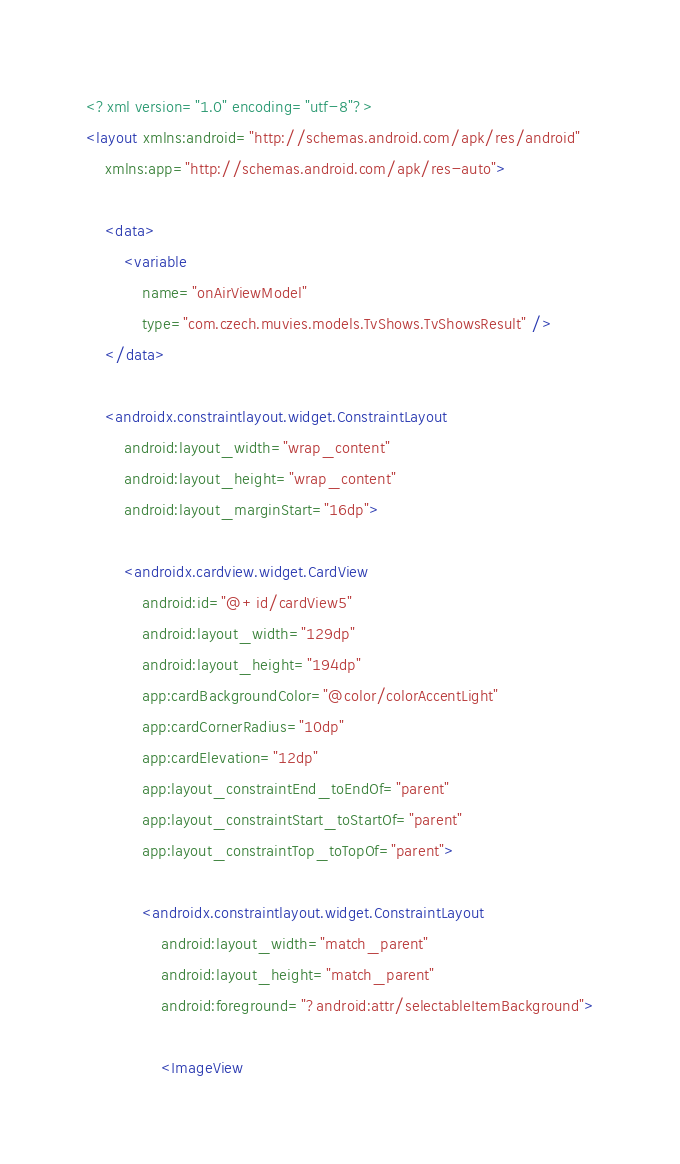<code> <loc_0><loc_0><loc_500><loc_500><_XML_><?xml version="1.0" encoding="utf-8"?>
<layout xmlns:android="http://schemas.android.com/apk/res/android"
    xmlns:app="http://schemas.android.com/apk/res-auto">

    <data>
        <variable
            name="onAirViewModel"
            type="com.czech.muvies.models.TvShows.TvShowsResult" />
    </data>

    <androidx.constraintlayout.widget.ConstraintLayout
        android:layout_width="wrap_content"
        android:layout_height="wrap_content"
        android:layout_marginStart="16dp">

        <androidx.cardview.widget.CardView
            android:id="@+id/cardView5"
            android:layout_width="129dp"
            android:layout_height="194dp"
            app:cardBackgroundColor="@color/colorAccentLight"
            app:cardCornerRadius="10dp"
            app:cardElevation="12dp"
            app:layout_constraintEnd_toEndOf="parent"
            app:layout_constraintStart_toStartOf="parent"
            app:layout_constraintTop_toTopOf="parent">

            <androidx.constraintlayout.widget.ConstraintLayout
                android:layout_width="match_parent"
                android:layout_height="match_parent"
                android:foreground="?android:attr/selectableItemBackground">

                <ImageView</code> 